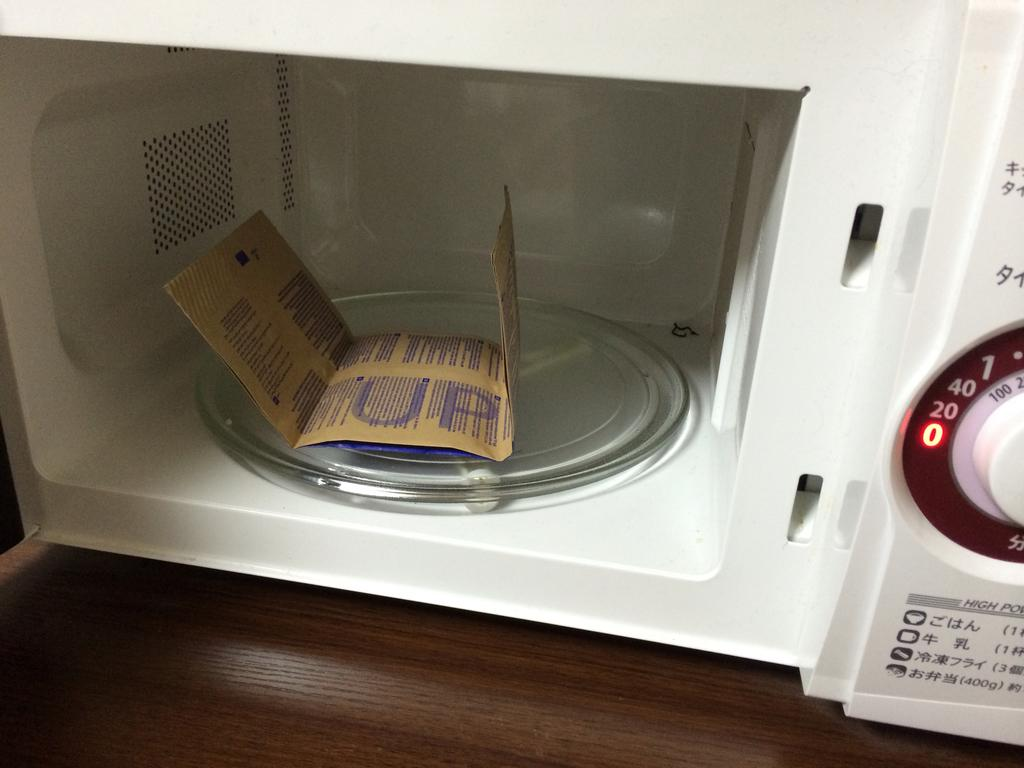<image>
Present a compact description of the photo's key features. UP is written on the microwave popcorn bag. 